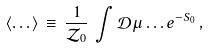<formula> <loc_0><loc_0><loc_500><loc_500>\langle \dots \rangle \, \equiv \, \frac { 1 } { \mathcal { Z } _ { 0 } } \, \int { \mathcal { D } } \mu \dots e ^ { - S _ { 0 } } \, ,</formula> 